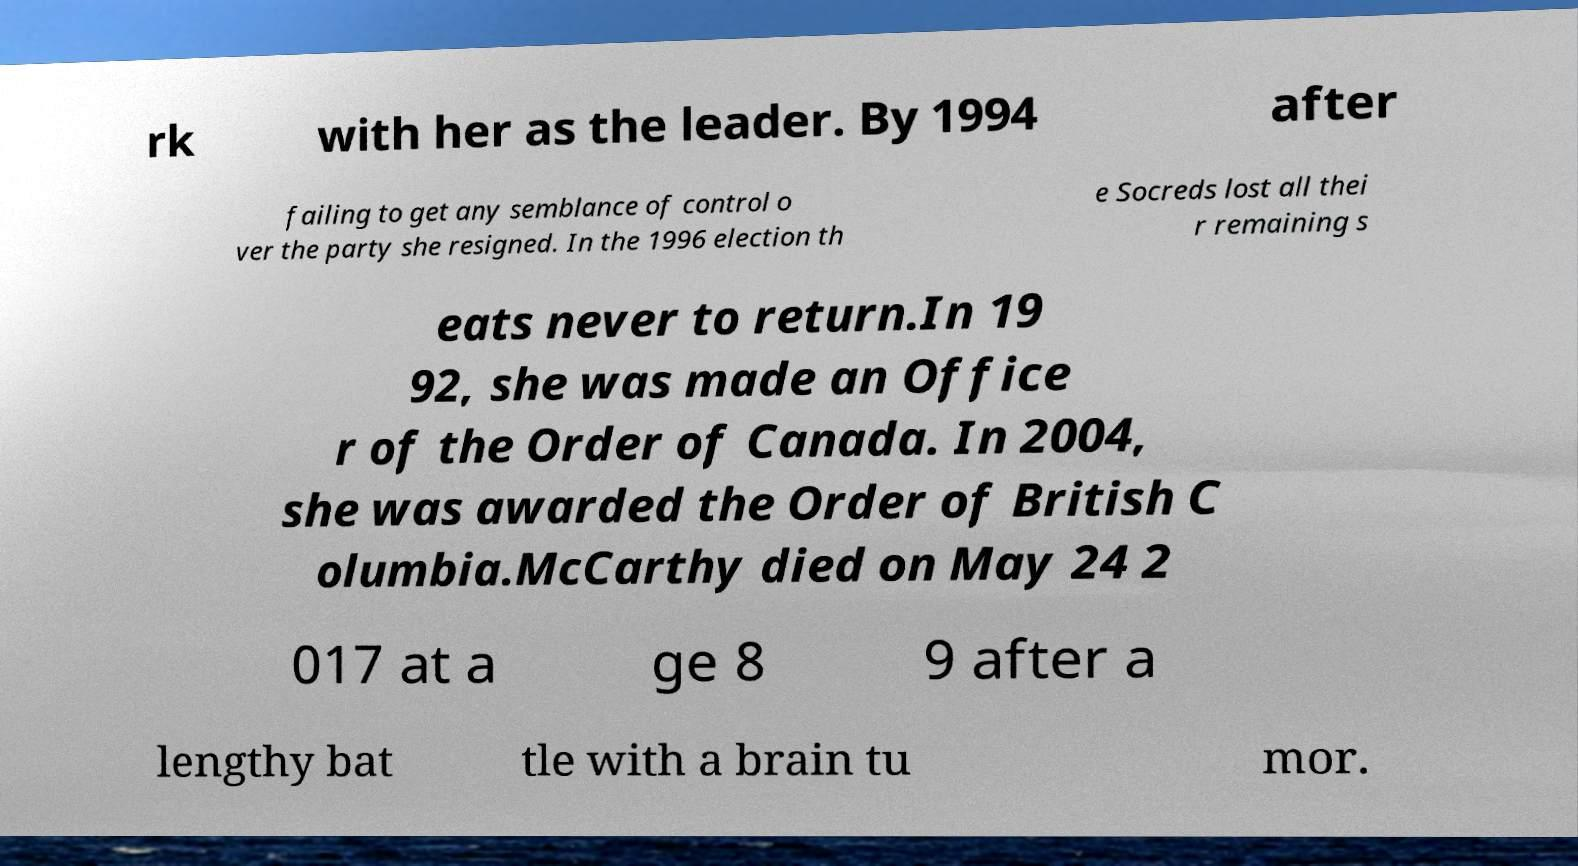Could you extract and type out the text from this image? rk with her as the leader. By 1994 after failing to get any semblance of control o ver the party she resigned. In the 1996 election th e Socreds lost all thei r remaining s eats never to return.In 19 92, she was made an Office r of the Order of Canada. In 2004, she was awarded the Order of British C olumbia.McCarthy died on May 24 2 017 at a ge 8 9 after a lengthy bat tle with a brain tu mor. 